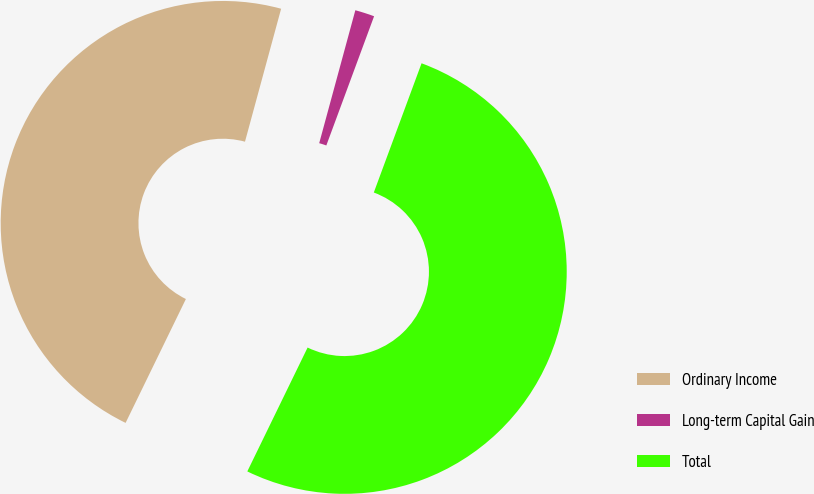Convert chart to OTSL. <chart><loc_0><loc_0><loc_500><loc_500><pie_chart><fcel>Ordinary Income<fcel>Long-term Capital Gain<fcel>Total<nl><fcel>47.01%<fcel>1.41%<fcel>51.57%<nl></chart> 